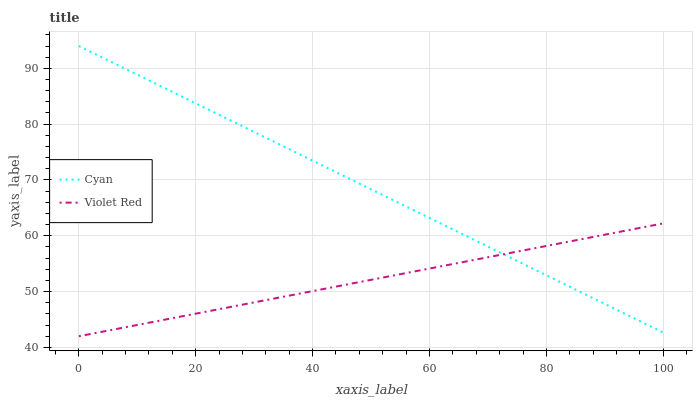Does Violet Red have the minimum area under the curve?
Answer yes or no. Yes. Does Cyan have the maximum area under the curve?
Answer yes or no. Yes. Does Violet Red have the maximum area under the curve?
Answer yes or no. No. Is Violet Red the smoothest?
Answer yes or no. Yes. Is Cyan the roughest?
Answer yes or no. Yes. Is Violet Red the roughest?
Answer yes or no. No. Does Violet Red have the lowest value?
Answer yes or no. Yes. Does Cyan have the highest value?
Answer yes or no. Yes. Does Violet Red have the highest value?
Answer yes or no. No. Does Violet Red intersect Cyan?
Answer yes or no. Yes. Is Violet Red less than Cyan?
Answer yes or no. No. Is Violet Red greater than Cyan?
Answer yes or no. No. 